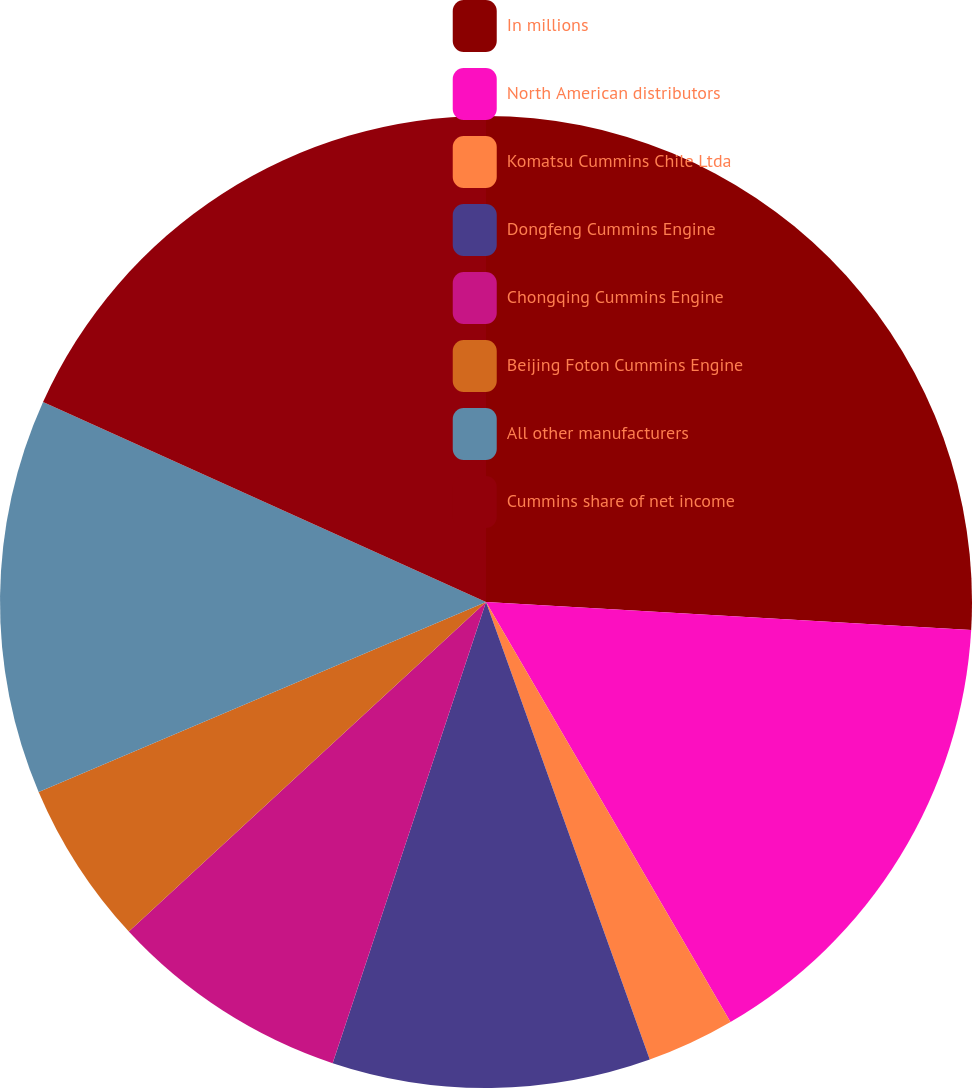<chart> <loc_0><loc_0><loc_500><loc_500><pie_chart><fcel>In millions<fcel>North American distributors<fcel>Komatsu Cummins Chile Ltda<fcel>Dongfeng Cummins Engine<fcel>Chongqing Cummins Engine<fcel>Beijing Foton Cummins Engine<fcel>All other manufacturers<fcel>Cummins share of net income<nl><fcel>25.92%<fcel>15.69%<fcel>2.92%<fcel>10.58%<fcel>8.03%<fcel>5.47%<fcel>13.14%<fcel>18.25%<nl></chart> 